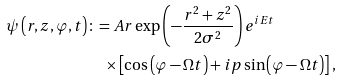<formula> <loc_0><loc_0><loc_500><loc_500>\psi \left ( r , z , \varphi , t \right ) & \colon = A r \exp \left ( - \frac { r ^ { 2 } + z ^ { 2 } } { 2 \sigma ^ { 2 } } \right ) e ^ { i E t } \\ & \quad \times \left [ \cos \left ( \varphi - \Omega t \right ) + i p \sin \left ( \varphi - \Omega t \right ) \right ] ,</formula> 